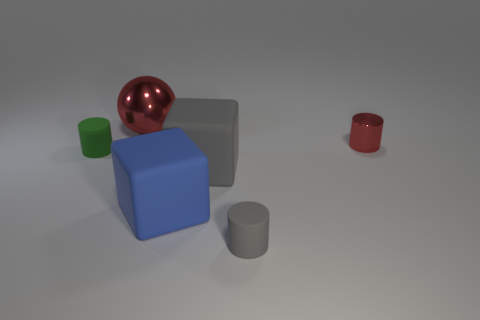What is the color of the big metallic ball?
Provide a succinct answer. Red. There is a cylinder left of the metal ball; is it the same color as the tiny metal object?
Your answer should be very brief. No. How many gray objects are shiny balls or tiny matte things?
Your answer should be compact. 1. How many other things are there of the same color as the metal cylinder?
Your answer should be very brief. 1. Is the number of large objects on the right side of the big red ball less than the number of red metal things?
Provide a short and direct response. No. There is a big object behind the large gray thing that is to the left of the small thing that is in front of the small green thing; what color is it?
Your answer should be very brief. Red. Is there anything else that is made of the same material as the green cylinder?
Offer a terse response. Yes. There is a red object that is the same shape as the green thing; what is its size?
Offer a very short reply. Small. Is the number of big objects that are behind the blue rubber cube less than the number of matte things right of the ball?
Your answer should be very brief. Yes. What shape is the tiny thing that is both in front of the red cylinder and on the right side of the red shiny sphere?
Give a very brief answer. Cylinder. 